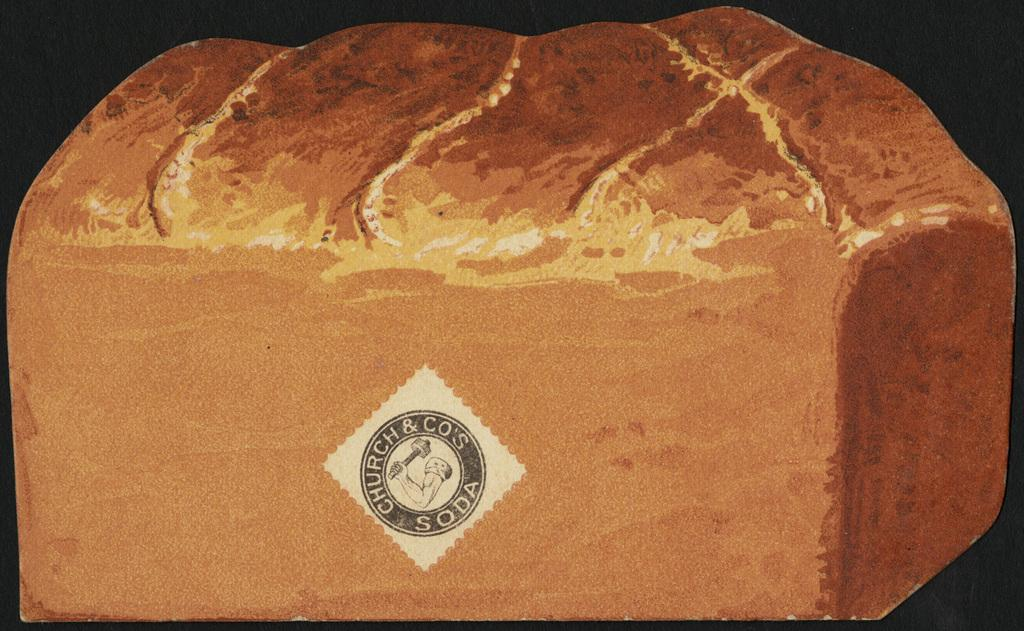What is on the object in the image? There is a sticker on an object in the image. What can be observed about the overall lighting in the image? The background of the image is dark. How many babies are crawling on the shirt in the image? There is no shirt or babies present in the image. What type of lizards can be seen climbing on the sticker in the image? There are no lizards present in the image; only a sticker on an object is visible. 